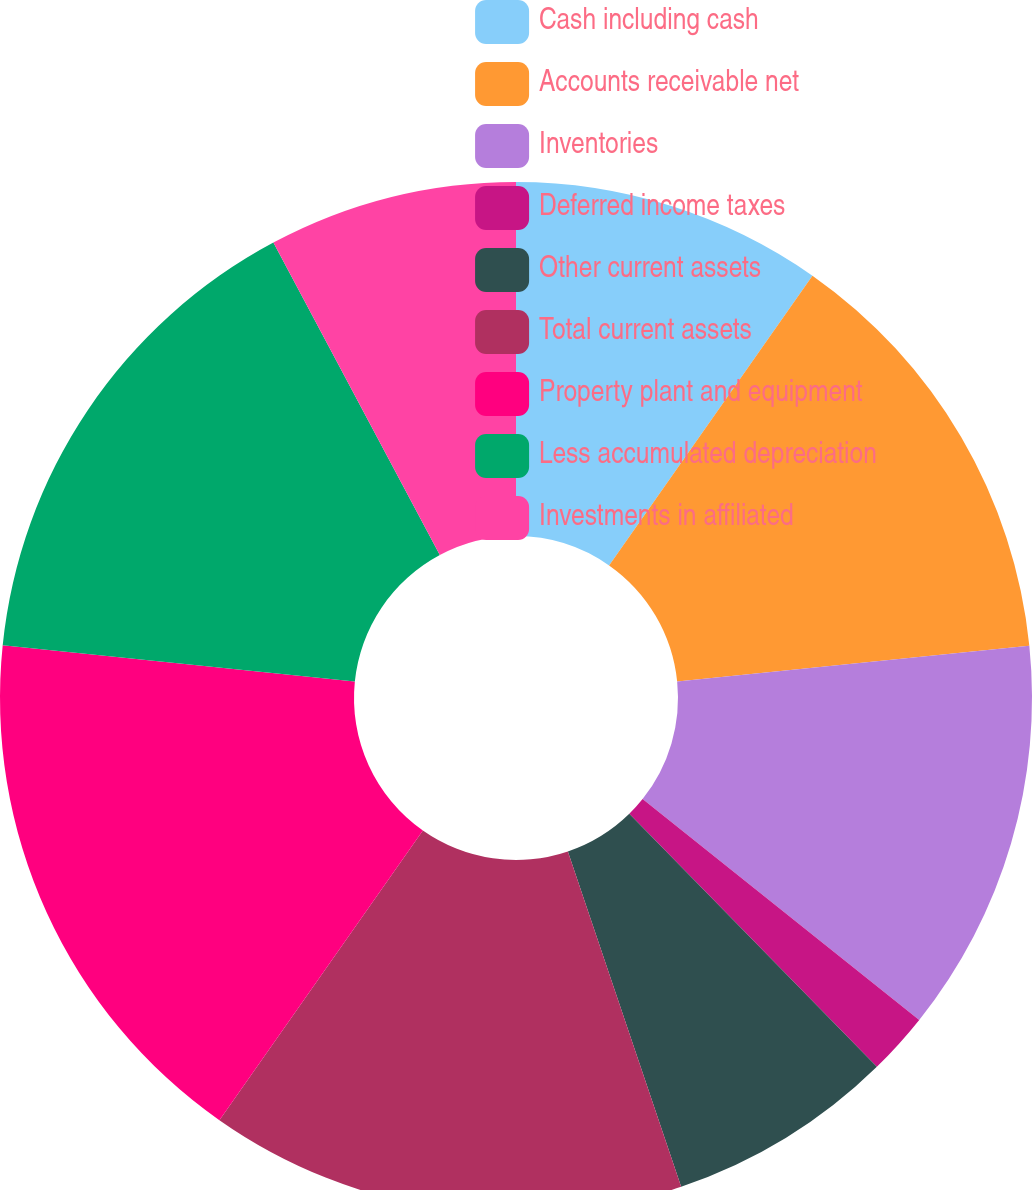<chart> <loc_0><loc_0><loc_500><loc_500><pie_chart><fcel>Cash including cash<fcel>Accounts receivable net<fcel>Inventories<fcel>Deferred income taxes<fcel>Other current assets<fcel>Total current assets<fcel>Property plant and equipment<fcel>Less accumulated depreciation<fcel>Investments in affiliated<nl><fcel>9.74%<fcel>13.64%<fcel>12.34%<fcel>1.95%<fcel>7.14%<fcel>14.93%<fcel>16.88%<fcel>15.58%<fcel>7.79%<nl></chart> 